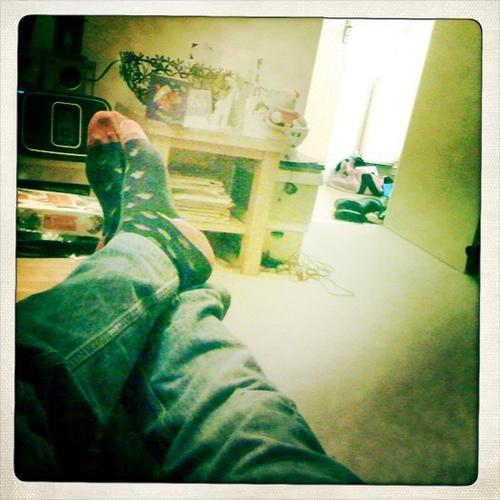What kind of pants are being worn?
Give a very brief answer. Jeans. Is it natural light?
Concise answer only. Yes. What design is on the socks?
Quick response, please. Diamonds. 